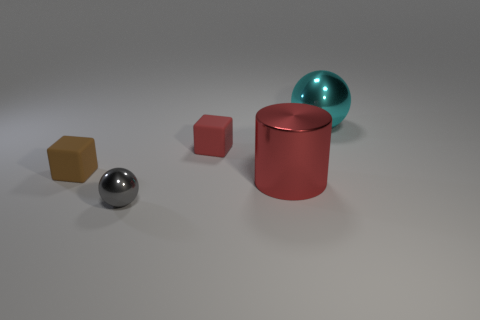What number of large spheres are there?
Make the answer very short. 1. Do the large object that is in front of the small red matte cube and the tiny matte object that is right of the gray metallic sphere have the same color?
Give a very brief answer. Yes. How many other things are there of the same size as the red matte object?
Make the answer very short. 2. The metal thing that is on the left side of the red metal cylinder is what color?
Make the answer very short. Gray. Does the cube to the right of the tiny metal thing have the same material as the big cylinder?
Your answer should be compact. No. How many metal balls are to the right of the tiny gray sphere and left of the large cyan sphere?
Provide a succinct answer. 0. There is a cube that is behind the rubber object that is in front of the matte object that is behind the brown rubber thing; what color is it?
Your response must be concise. Red. What number of other objects are there of the same shape as the red metal thing?
Give a very brief answer. 0. Is there a small rubber thing in front of the matte thing that is right of the tiny gray metallic thing?
Your response must be concise. Yes. What number of matte things are gray objects or large spheres?
Give a very brief answer. 0. 